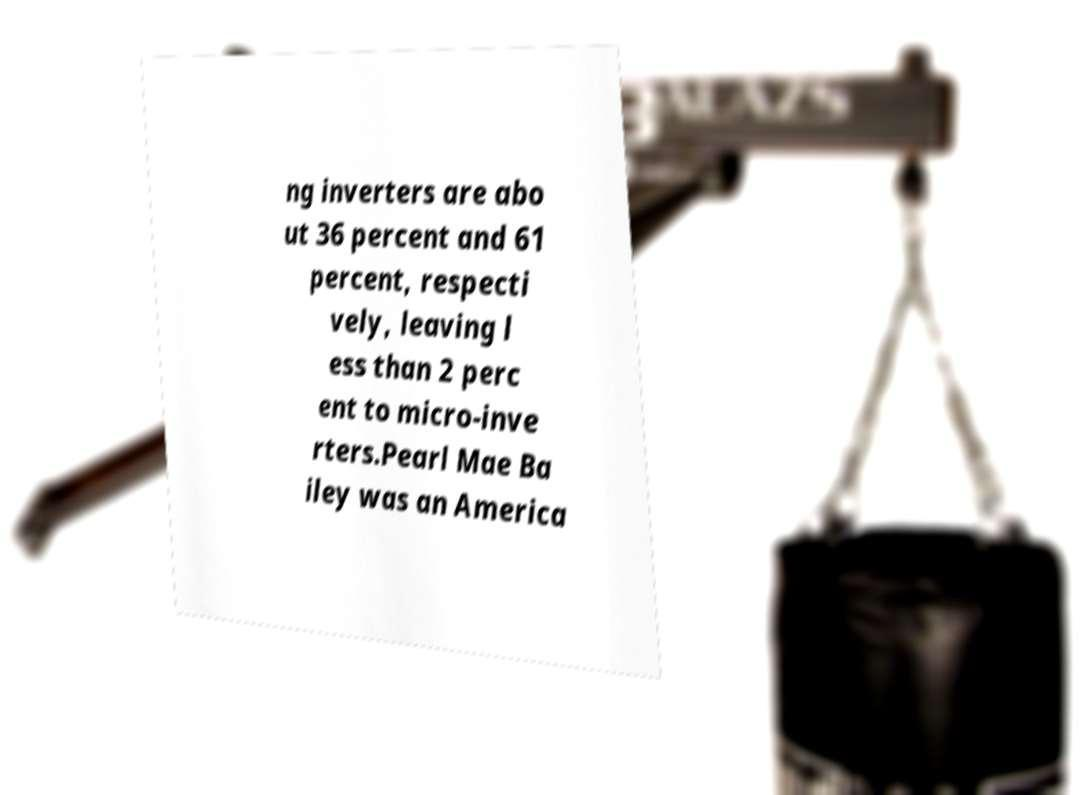For documentation purposes, I need the text within this image transcribed. Could you provide that? ng inverters are abo ut 36 percent and 61 percent, respecti vely, leaving l ess than 2 perc ent to micro-inve rters.Pearl Mae Ba iley was an America 